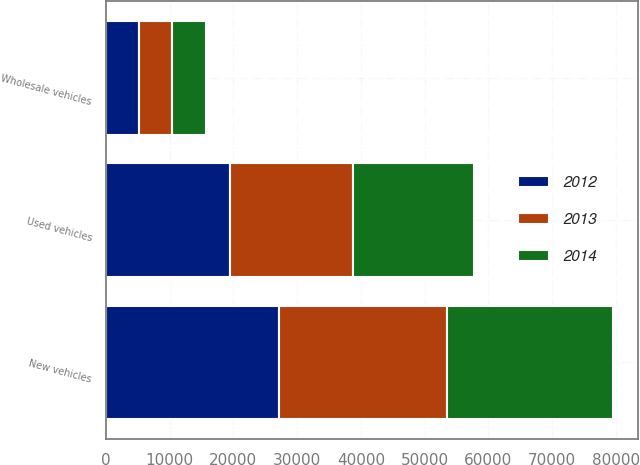Convert chart to OTSL. <chart><loc_0><loc_0><loc_500><loc_500><stacked_bar_chart><ecel><fcel>Used vehicles<fcel>New vehicles<fcel>Wholesale vehicles<nl><fcel>2012<fcel>19408<fcel>27205<fcel>5160<nl><fcel>2013<fcel>19351<fcel>26316<fcel>5268<nl><fcel>2014<fcel>18995<fcel>25986<fcel>5291<nl></chart> 